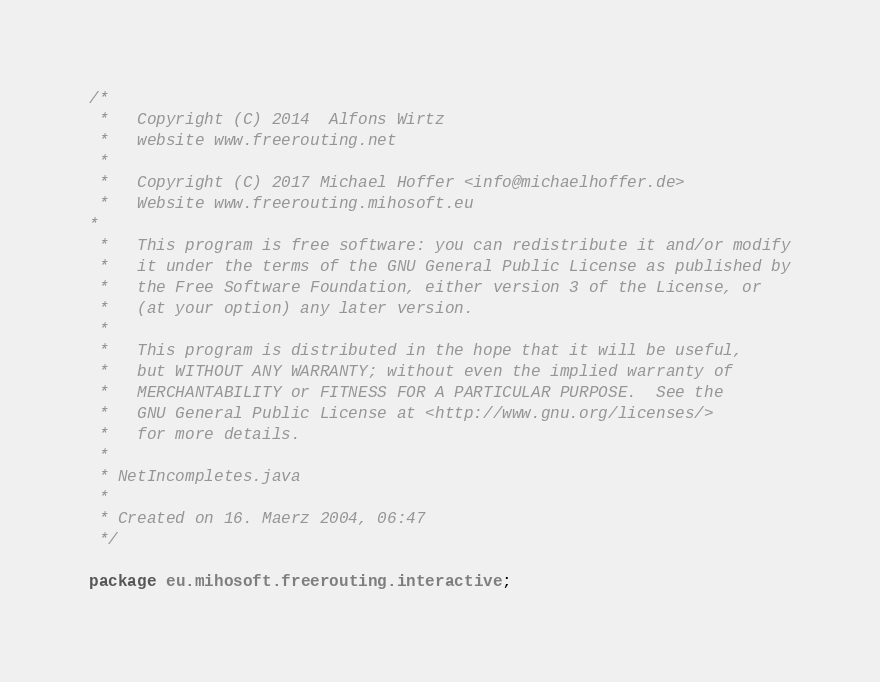<code> <loc_0><loc_0><loc_500><loc_500><_Java_>/*
 *   Copyright (C) 2014  Alfons Wirtz
 *   website www.freerouting.net
 *
 *   Copyright (C) 2017 Michael Hoffer <info@michaelhoffer.de>
 *   Website www.freerouting.mihosoft.eu
*
 *   This program is free software: you can redistribute it and/or modify
 *   it under the terms of the GNU General Public License as published by
 *   the Free Software Foundation, either version 3 of the License, or
 *   (at your option) any later version.
 *
 *   This program is distributed in the hope that it will be useful,
 *   but WITHOUT ANY WARRANTY; without even the implied warranty of
 *   MERCHANTABILITY or FITNESS FOR A PARTICULAR PURPOSE.  See the
 *   GNU General Public License at <http://www.gnu.org/licenses/> 
 *   for more details.
 *
 * NetIncompletes.java
 *
 * Created on 16. Maerz 2004, 06:47
 */

package eu.mihosoft.freerouting.interactive;
</code> 